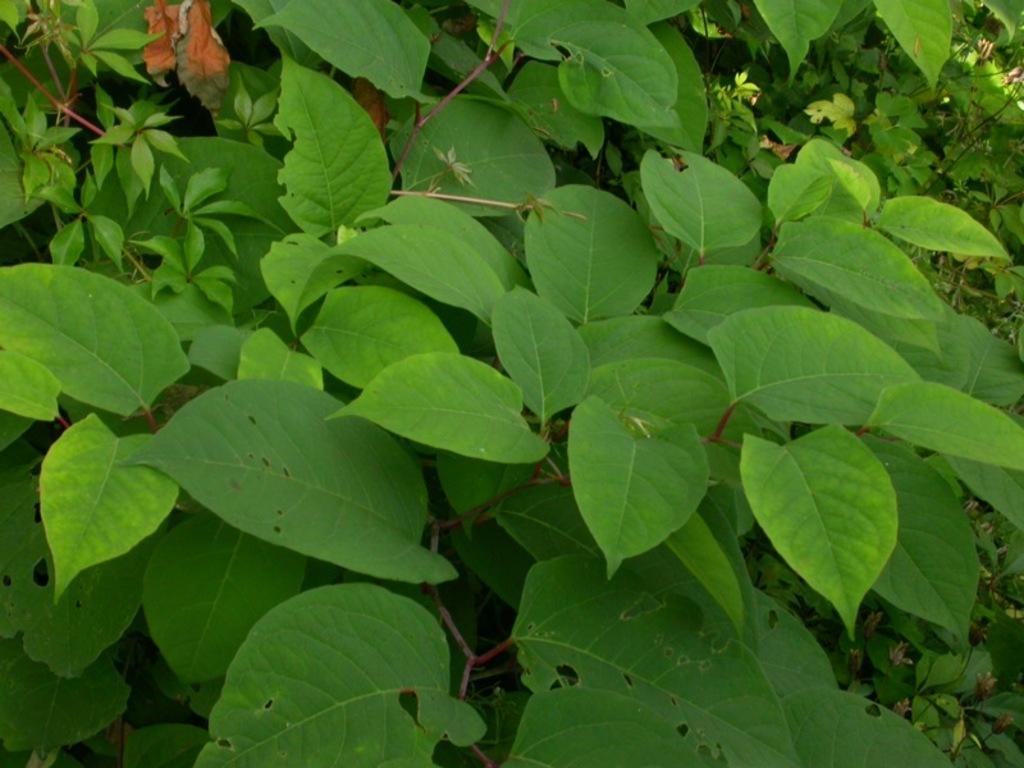Could you give a brief overview of what you see in this image? In this image I can see there are plants. 